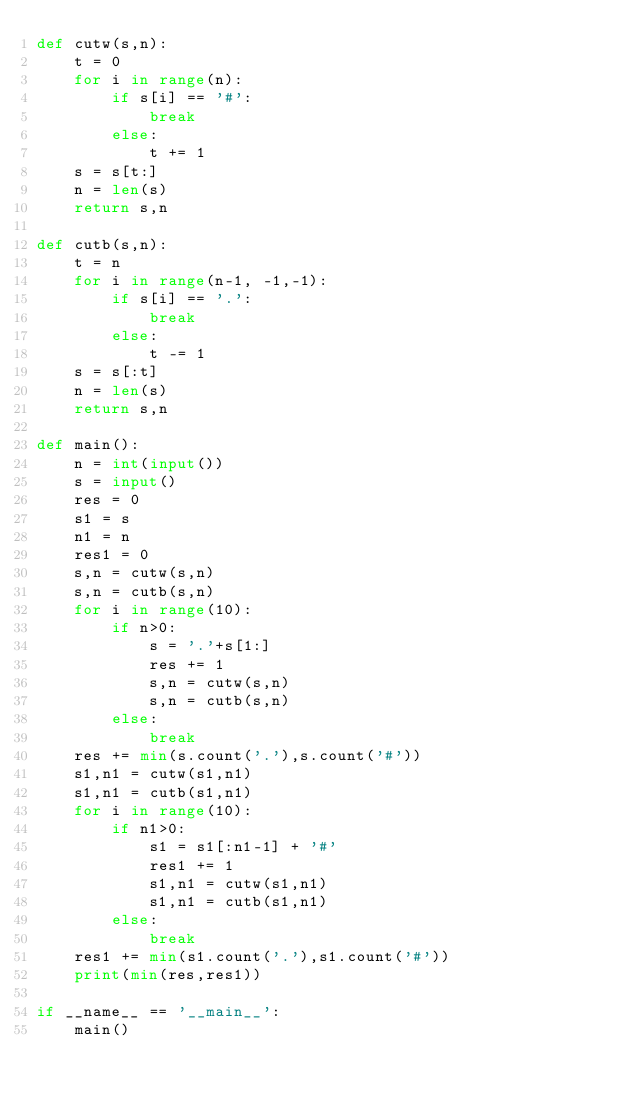Convert code to text. <code><loc_0><loc_0><loc_500><loc_500><_Python_>def cutw(s,n):
    t = 0
    for i in range(n):
        if s[i] == '#':
            break
        else:
            t += 1
    s = s[t:]
    n = len(s)
    return s,n

def cutb(s,n):
    t = n
    for i in range(n-1, -1,-1):
        if s[i] == '.':
            break
        else:
            t -= 1
    s = s[:t]
    n = len(s)
    return s,n

def main():
    n = int(input())
    s = input()
    res = 0
    s1 = s
    n1 = n
    res1 = 0
    s,n = cutw(s,n)
    s,n = cutb(s,n)
    for i in range(10):
        if n>0:
            s = '.'+s[1:]
            res += 1
            s,n = cutw(s,n)
            s,n = cutb(s,n)
        else:
            break
    res += min(s.count('.'),s.count('#'))
    s1,n1 = cutw(s1,n1)
    s1,n1 = cutb(s1,n1)
    for i in range(10):
        if n1>0:
            s1 = s1[:n1-1] + '#'
            res1 += 1
            s1,n1 = cutw(s1,n1)
            s1,n1 = cutb(s1,n1)
        else:
            break
    res1 += min(s1.count('.'),s1.count('#'))
    print(min(res,res1))

if __name__ == '__main__':
    main()
</code> 